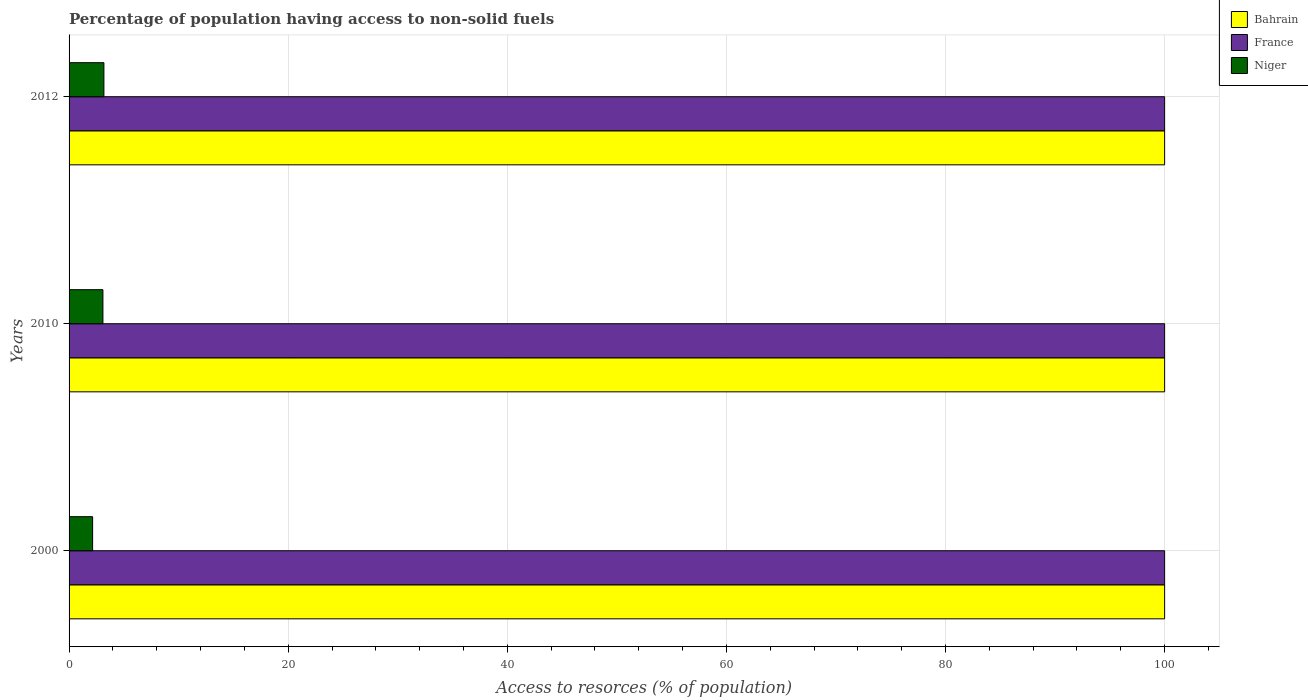Are the number of bars on each tick of the Y-axis equal?
Your answer should be compact. Yes. In how many cases, is the number of bars for a given year not equal to the number of legend labels?
Your answer should be compact. 0. What is the percentage of population having access to non-solid fuels in Niger in 2000?
Keep it short and to the point. 2.15. Across all years, what is the maximum percentage of population having access to non-solid fuels in Bahrain?
Keep it short and to the point. 100. Across all years, what is the minimum percentage of population having access to non-solid fuels in Niger?
Ensure brevity in your answer.  2.15. In which year was the percentage of population having access to non-solid fuels in Bahrain maximum?
Ensure brevity in your answer.  2000. In which year was the percentage of population having access to non-solid fuels in Niger minimum?
Keep it short and to the point. 2000. What is the total percentage of population having access to non-solid fuels in Bahrain in the graph?
Provide a short and direct response. 300. What is the difference between the percentage of population having access to non-solid fuels in Niger in 2000 and that in 2010?
Make the answer very short. -0.94. What is the difference between the percentage of population having access to non-solid fuels in Bahrain in 2010 and the percentage of population having access to non-solid fuels in France in 2012?
Provide a succinct answer. 0. In how many years, is the percentage of population having access to non-solid fuels in Bahrain greater than 68 %?
Ensure brevity in your answer.  3. What is the ratio of the percentage of population having access to non-solid fuels in France in 2000 to that in 2010?
Offer a terse response. 1. Is the sum of the percentage of population having access to non-solid fuels in Niger in 2000 and 2010 greater than the maximum percentage of population having access to non-solid fuels in Bahrain across all years?
Make the answer very short. No. What does the 3rd bar from the top in 2010 represents?
Make the answer very short. Bahrain. What does the 1st bar from the bottom in 2000 represents?
Provide a succinct answer. Bahrain. Is it the case that in every year, the sum of the percentage of population having access to non-solid fuels in Niger and percentage of population having access to non-solid fuels in France is greater than the percentage of population having access to non-solid fuels in Bahrain?
Provide a succinct answer. Yes. How many bars are there?
Offer a terse response. 9. How many years are there in the graph?
Offer a terse response. 3. What is the difference between two consecutive major ticks on the X-axis?
Provide a succinct answer. 20. Does the graph contain grids?
Ensure brevity in your answer.  Yes. Where does the legend appear in the graph?
Offer a terse response. Top right. How many legend labels are there?
Keep it short and to the point. 3. What is the title of the graph?
Offer a terse response. Percentage of population having access to non-solid fuels. Does "Belize" appear as one of the legend labels in the graph?
Ensure brevity in your answer.  No. What is the label or title of the X-axis?
Your response must be concise. Access to resorces (% of population). What is the label or title of the Y-axis?
Your answer should be very brief. Years. What is the Access to resorces (% of population) in France in 2000?
Give a very brief answer. 100. What is the Access to resorces (% of population) in Niger in 2000?
Give a very brief answer. 2.15. What is the Access to resorces (% of population) of Bahrain in 2010?
Your answer should be very brief. 100. What is the Access to resorces (% of population) in France in 2010?
Make the answer very short. 100. What is the Access to resorces (% of population) in Niger in 2010?
Give a very brief answer. 3.09. What is the Access to resorces (% of population) in France in 2012?
Your answer should be very brief. 100. What is the Access to resorces (% of population) of Niger in 2012?
Your response must be concise. 3.18. Across all years, what is the maximum Access to resorces (% of population) of Bahrain?
Your response must be concise. 100. Across all years, what is the maximum Access to resorces (% of population) in France?
Your response must be concise. 100. Across all years, what is the maximum Access to resorces (% of population) in Niger?
Your response must be concise. 3.18. Across all years, what is the minimum Access to resorces (% of population) of Bahrain?
Provide a succinct answer. 100. Across all years, what is the minimum Access to resorces (% of population) in France?
Offer a terse response. 100. Across all years, what is the minimum Access to resorces (% of population) in Niger?
Your answer should be very brief. 2.15. What is the total Access to resorces (% of population) in Bahrain in the graph?
Keep it short and to the point. 300. What is the total Access to resorces (% of population) in France in the graph?
Make the answer very short. 300. What is the total Access to resorces (% of population) of Niger in the graph?
Provide a succinct answer. 8.42. What is the difference between the Access to resorces (% of population) in Niger in 2000 and that in 2010?
Provide a short and direct response. -0.94. What is the difference between the Access to resorces (% of population) of France in 2000 and that in 2012?
Your answer should be very brief. 0. What is the difference between the Access to resorces (% of population) in Niger in 2000 and that in 2012?
Offer a terse response. -1.03. What is the difference between the Access to resorces (% of population) in Bahrain in 2010 and that in 2012?
Give a very brief answer. 0. What is the difference between the Access to resorces (% of population) of France in 2010 and that in 2012?
Offer a terse response. 0. What is the difference between the Access to resorces (% of population) of Niger in 2010 and that in 2012?
Your answer should be compact. -0.09. What is the difference between the Access to resorces (% of population) of Bahrain in 2000 and the Access to resorces (% of population) of Niger in 2010?
Provide a short and direct response. 96.91. What is the difference between the Access to resorces (% of population) of France in 2000 and the Access to resorces (% of population) of Niger in 2010?
Give a very brief answer. 96.91. What is the difference between the Access to resorces (% of population) of Bahrain in 2000 and the Access to resorces (% of population) of France in 2012?
Offer a terse response. 0. What is the difference between the Access to resorces (% of population) in Bahrain in 2000 and the Access to resorces (% of population) in Niger in 2012?
Your response must be concise. 96.82. What is the difference between the Access to resorces (% of population) in France in 2000 and the Access to resorces (% of population) in Niger in 2012?
Ensure brevity in your answer.  96.82. What is the difference between the Access to resorces (% of population) in Bahrain in 2010 and the Access to resorces (% of population) in France in 2012?
Make the answer very short. 0. What is the difference between the Access to resorces (% of population) of Bahrain in 2010 and the Access to resorces (% of population) of Niger in 2012?
Provide a short and direct response. 96.82. What is the difference between the Access to resorces (% of population) of France in 2010 and the Access to resorces (% of population) of Niger in 2012?
Offer a terse response. 96.82. What is the average Access to resorces (% of population) of France per year?
Keep it short and to the point. 100. What is the average Access to resorces (% of population) in Niger per year?
Provide a short and direct response. 2.81. In the year 2000, what is the difference between the Access to resorces (% of population) in Bahrain and Access to resorces (% of population) in Niger?
Offer a very short reply. 97.85. In the year 2000, what is the difference between the Access to resorces (% of population) of France and Access to resorces (% of population) of Niger?
Your response must be concise. 97.85. In the year 2010, what is the difference between the Access to resorces (% of population) of Bahrain and Access to resorces (% of population) of Niger?
Keep it short and to the point. 96.91. In the year 2010, what is the difference between the Access to resorces (% of population) of France and Access to resorces (% of population) of Niger?
Give a very brief answer. 96.91. In the year 2012, what is the difference between the Access to resorces (% of population) of Bahrain and Access to resorces (% of population) of France?
Your answer should be very brief. 0. In the year 2012, what is the difference between the Access to resorces (% of population) of Bahrain and Access to resorces (% of population) of Niger?
Ensure brevity in your answer.  96.82. In the year 2012, what is the difference between the Access to resorces (% of population) of France and Access to resorces (% of population) of Niger?
Offer a very short reply. 96.82. What is the ratio of the Access to resorces (% of population) in France in 2000 to that in 2010?
Your answer should be very brief. 1. What is the ratio of the Access to resorces (% of population) of Niger in 2000 to that in 2010?
Your response must be concise. 0.7. What is the ratio of the Access to resorces (% of population) in Bahrain in 2000 to that in 2012?
Offer a terse response. 1. What is the ratio of the Access to resorces (% of population) in Niger in 2000 to that in 2012?
Ensure brevity in your answer.  0.68. What is the ratio of the Access to resorces (% of population) in Bahrain in 2010 to that in 2012?
Ensure brevity in your answer.  1. What is the ratio of the Access to resorces (% of population) in Niger in 2010 to that in 2012?
Make the answer very short. 0.97. What is the difference between the highest and the second highest Access to resorces (% of population) of Niger?
Ensure brevity in your answer.  0.09. What is the difference between the highest and the lowest Access to resorces (% of population) in Bahrain?
Make the answer very short. 0. What is the difference between the highest and the lowest Access to resorces (% of population) in France?
Ensure brevity in your answer.  0. What is the difference between the highest and the lowest Access to resorces (% of population) of Niger?
Give a very brief answer. 1.03. 